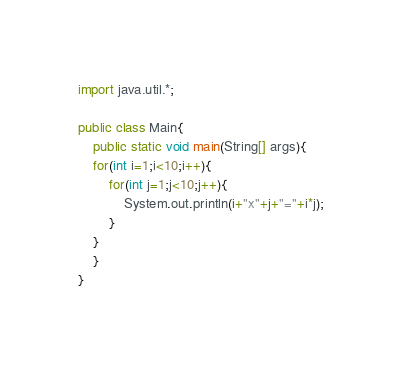Convert code to text. <code><loc_0><loc_0><loc_500><loc_500><_Java_>import java.util.*;

public class Main{
    public static void main(String[] args){
	for(int i=1;i<10;i++){
		for(int j=1;j<10;j++){
			System.out.println(i+"x"+j+"="+i*j);
		}
	}
    }
}
</code> 